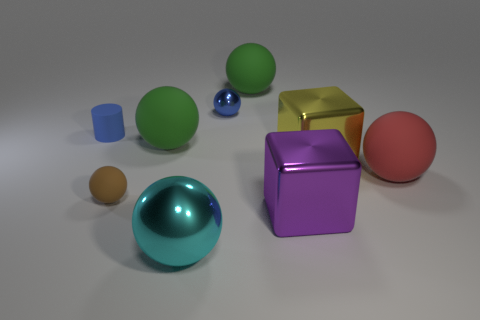Subtract all yellow cylinders. How many green spheres are left? 2 Subtract all cyan spheres. How many spheres are left? 5 Subtract 3 spheres. How many spheres are left? 3 Subtract all brown matte spheres. How many spheres are left? 5 Add 1 yellow blocks. How many objects exist? 10 Subtract all cyan balls. Subtract all purple cubes. How many balls are left? 5 Subtract all cylinders. How many objects are left? 8 Add 9 big purple spheres. How many big purple spheres exist? 9 Subtract 0 red blocks. How many objects are left? 9 Subtract all large blue spheres. Subtract all large yellow metallic objects. How many objects are left? 8 